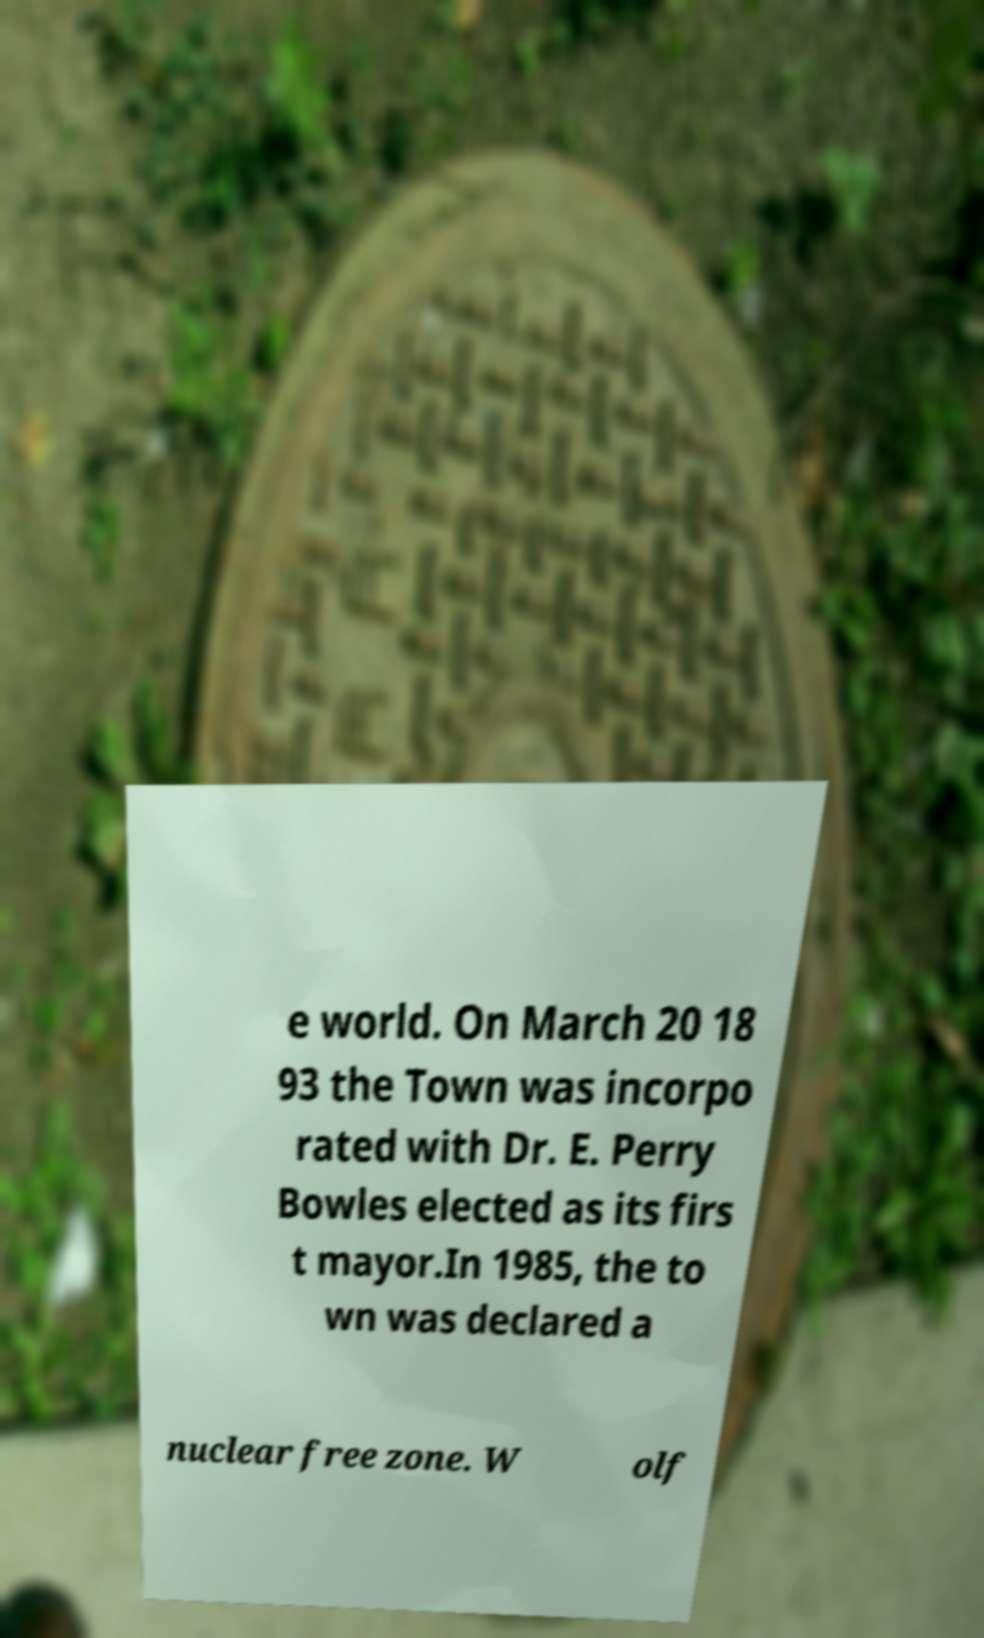Please identify and transcribe the text found in this image. e world. On March 20 18 93 the Town was incorpo rated with Dr. E. Perry Bowles elected as its firs t mayor.In 1985, the to wn was declared a nuclear free zone. W olf 